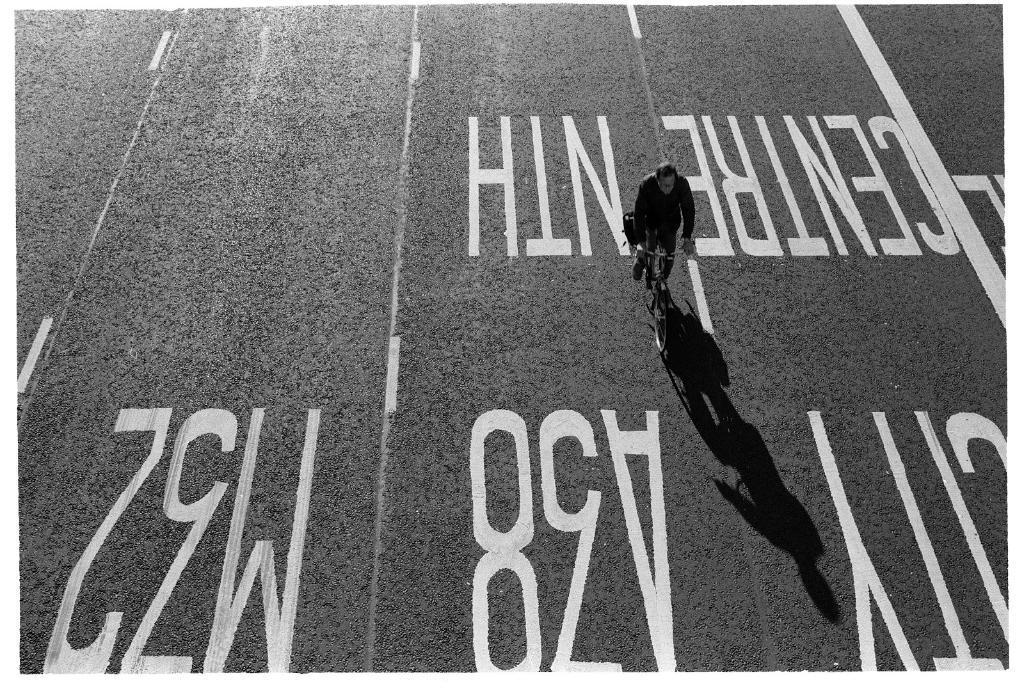<image>
Offer a succinct explanation of the picture presented. a person biking on a road with M32 and A38 painted on 